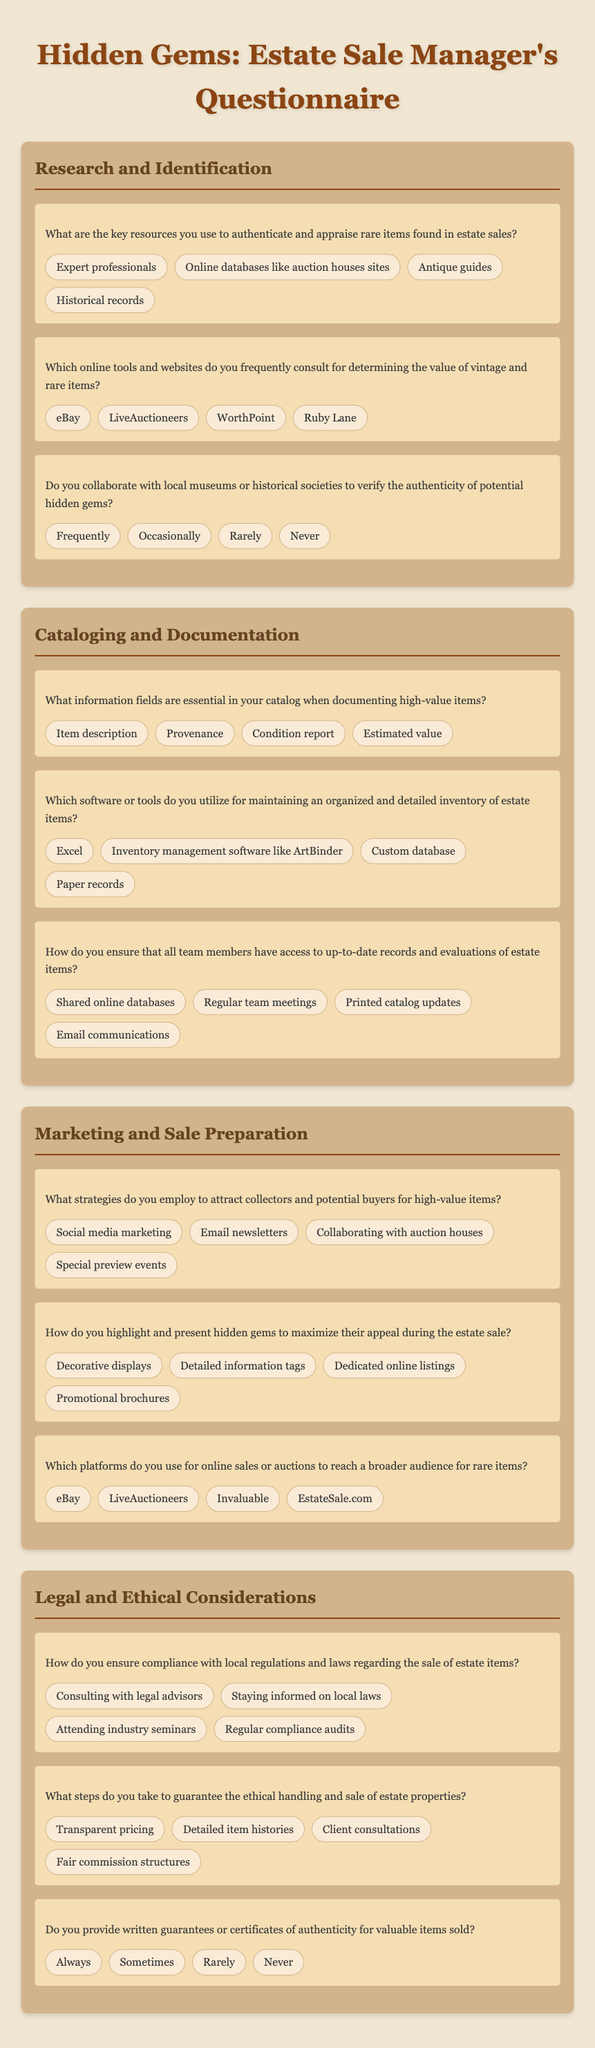What is the title of the questionnaire? The title of the questionnaire is prominently displayed at the top of the document.
Answer: Hidden Gems: Estate Sale Manager's Questionnaire Which category includes questions about marketing strategies? The categories are clearly labeled, and one specifically addresses marketing and sale preparation.
Answer: Marketing and Sale Preparation What is a key resource for authenticating rare items mentioned in the document? The options for authenticating rare items are listed in the research and identification category.
Answer: Expert professionals How do estate sale managers document high-value items? A specific question addresses essential information fields in cataloging high-value items.
Answer: Item description What platform is mentioned for online sales of rare items? The document lists several platforms under online sales or auctions in the marketing category.
Answer: eBay Which option describes the method for maintaining organized inventory? The options regarding software or tools used for cataloging are included in the cataloging category.
Answer: Inventory management software like ArtBinder How often do managers collaborate with local museums? The frequency of collaboration with local museums is assessed in the research section of the questionnaire.
Answer: Occasionally What steps are taken to ensure ethical handling of estate items? Ethical steps are outlined in the legal and ethical considerations category.
Answer: Transparent pricing Do estate sale managers provide certificates of authenticity? The questionnaire specifically asks about the provision of written guarantees for valuable items sold.
Answer: Always 